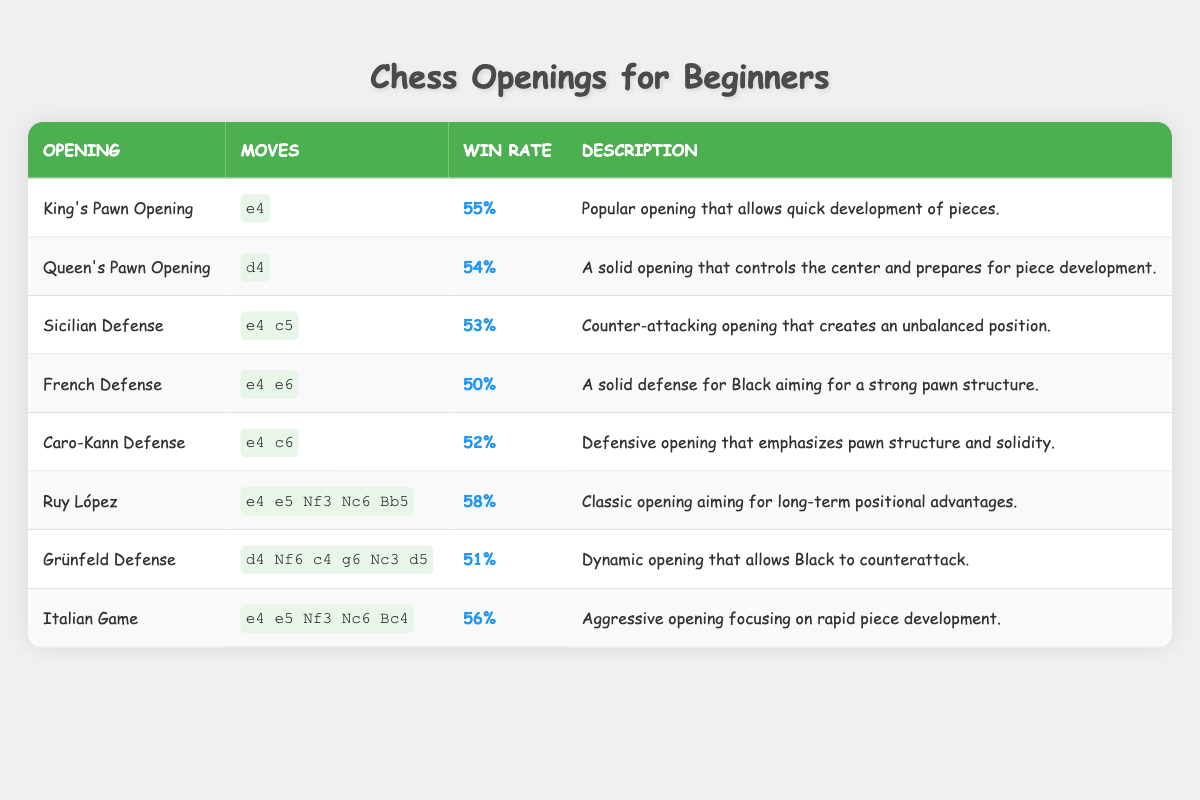What is the win rate for the Italian Game? You can find the win rate for the Italian Game in the table. It is listed in the "Win Rate" column next to the Italian Game. The value is 56%.
Answer: 56% Which opening has the highest win rate? By looking at the "Win Rate" column, the Ruy López has the highest value at 58%.
Answer: Ruy López What are the moves associated with the Caro-Kann Defense? The moves for the Caro-Kann Defense can be found in the "Moves" column next to the Caro-Kann Defense opening. They are e4 c6.
Answer: e4 c6 Is the win rate of the French Defense higher than that of the Sicilian Defense? The win rate for the French Defense is 50%, and for the Sicilian Defense, it is 53%. Since 50% is not higher than 53%, the answer is no.
Answer: No What is the average win rate of all openings listed in the table? To find the average, add all the win rates: 55 + 54 + 53 + 50 + 52 + 58 + 51 + 56 = 429. There are 8 openings, so divide the total by 8: 429 / 8 = 53.625, which can be rounded to 53.6.
Answer: 53.6 